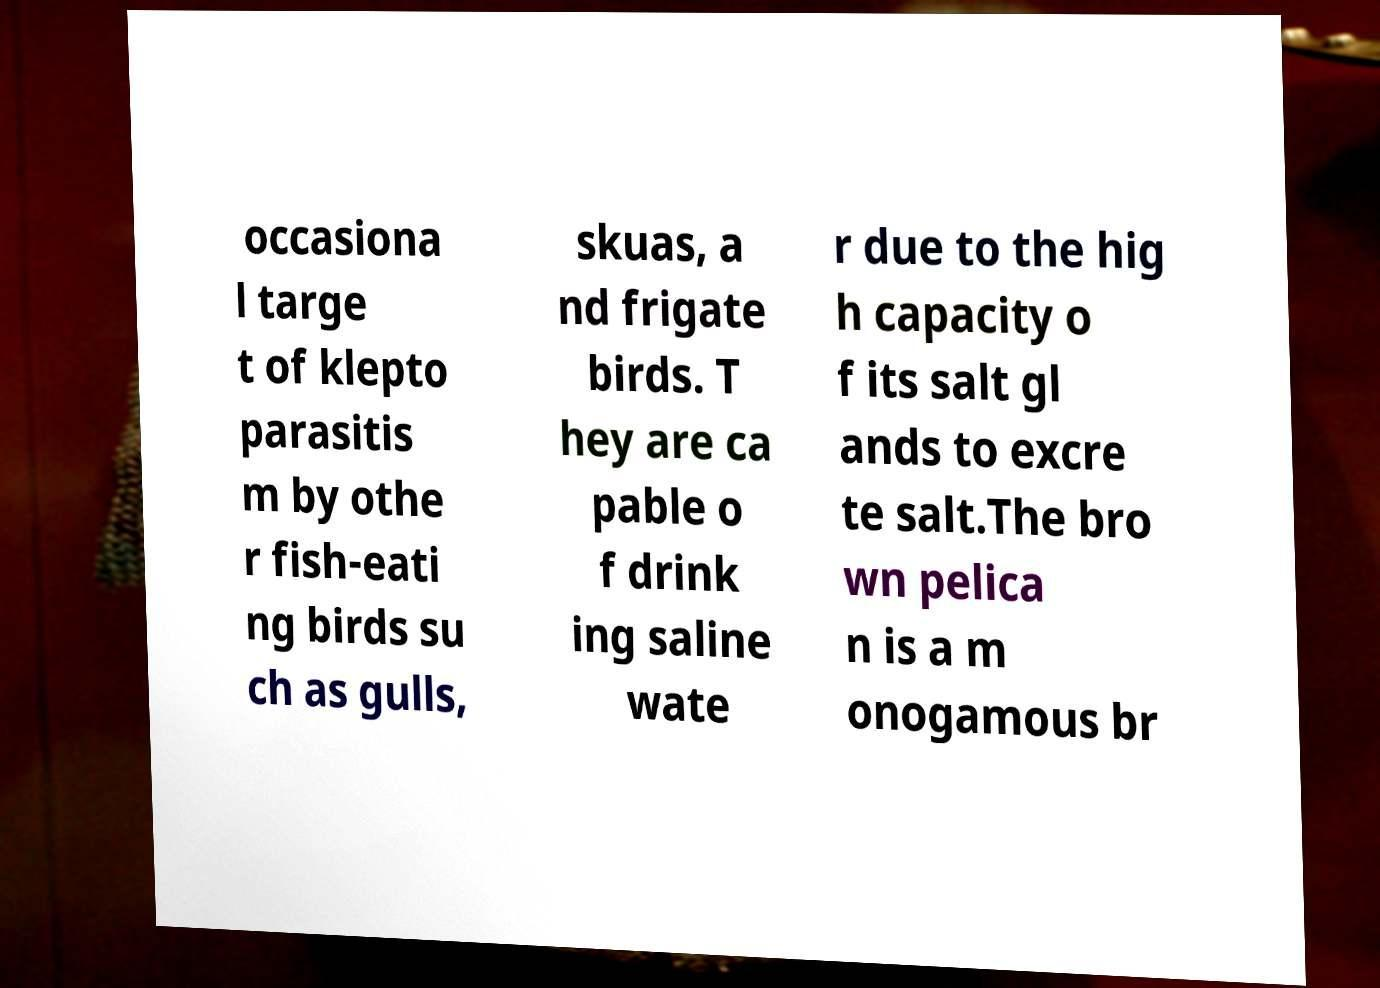Can you accurately transcribe the text from the provided image for me? occasiona l targe t of klepto parasitis m by othe r fish-eati ng birds su ch as gulls, skuas, a nd frigate birds. T hey are ca pable o f drink ing saline wate r due to the hig h capacity o f its salt gl ands to excre te salt.The bro wn pelica n is a m onogamous br 